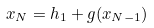<formula> <loc_0><loc_0><loc_500><loc_500>x _ { N } = h _ { 1 } + g ( x _ { N - 1 } )</formula> 